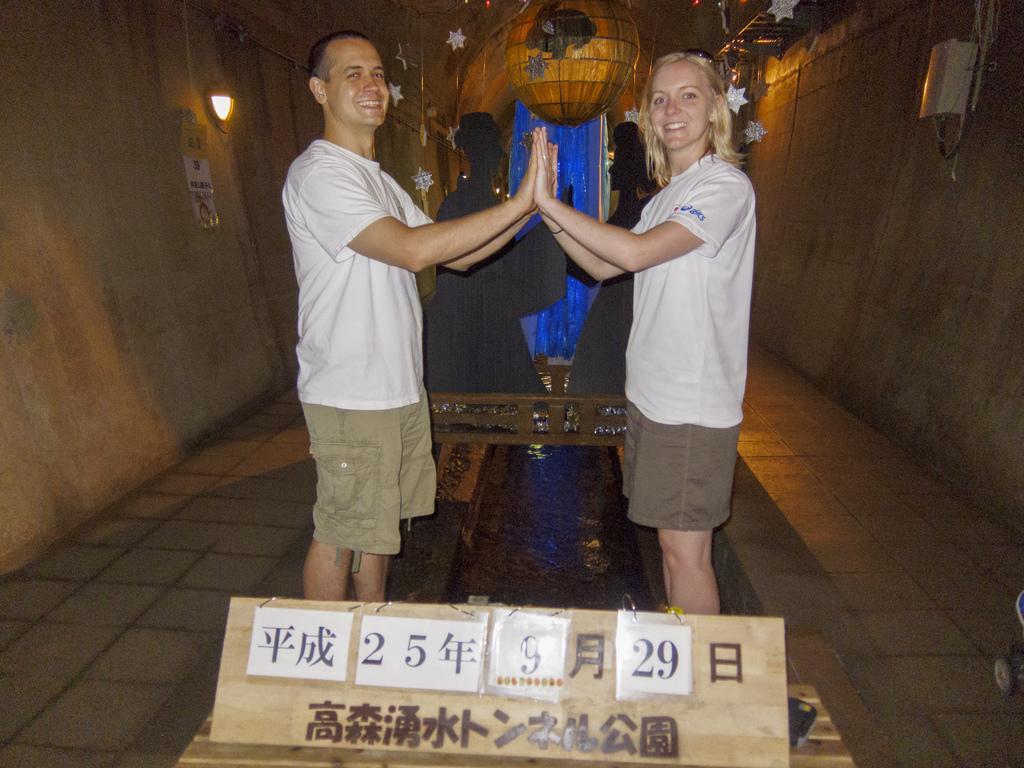In one or two sentences, can you explain what this image depicts? In this image there are sculptors of persons on a surface, there are two persons standing, there is a board on the surface, there are text and numbers on the board, there are stars, there is an object truncated towards the top of the image, there is a light, there is poster on the wall, there is a wall truncated towards the right of the image. 